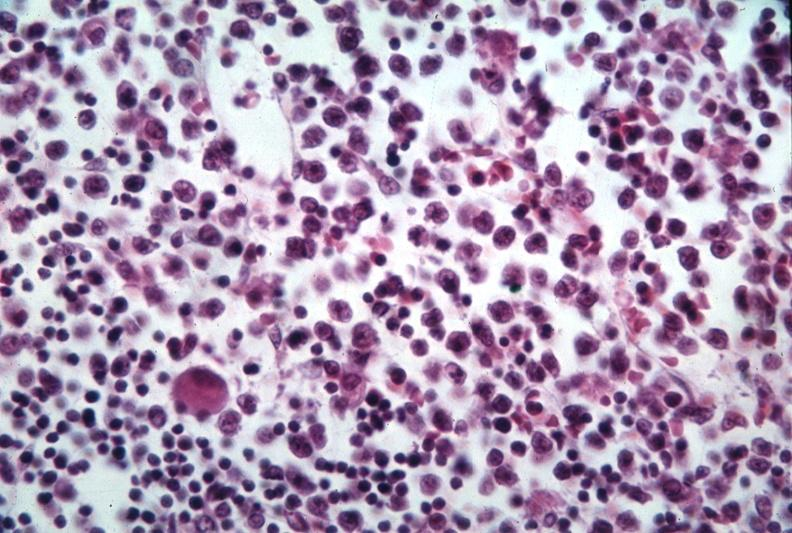s bone, mandible present?
Answer the question using a single word or phrase. No 